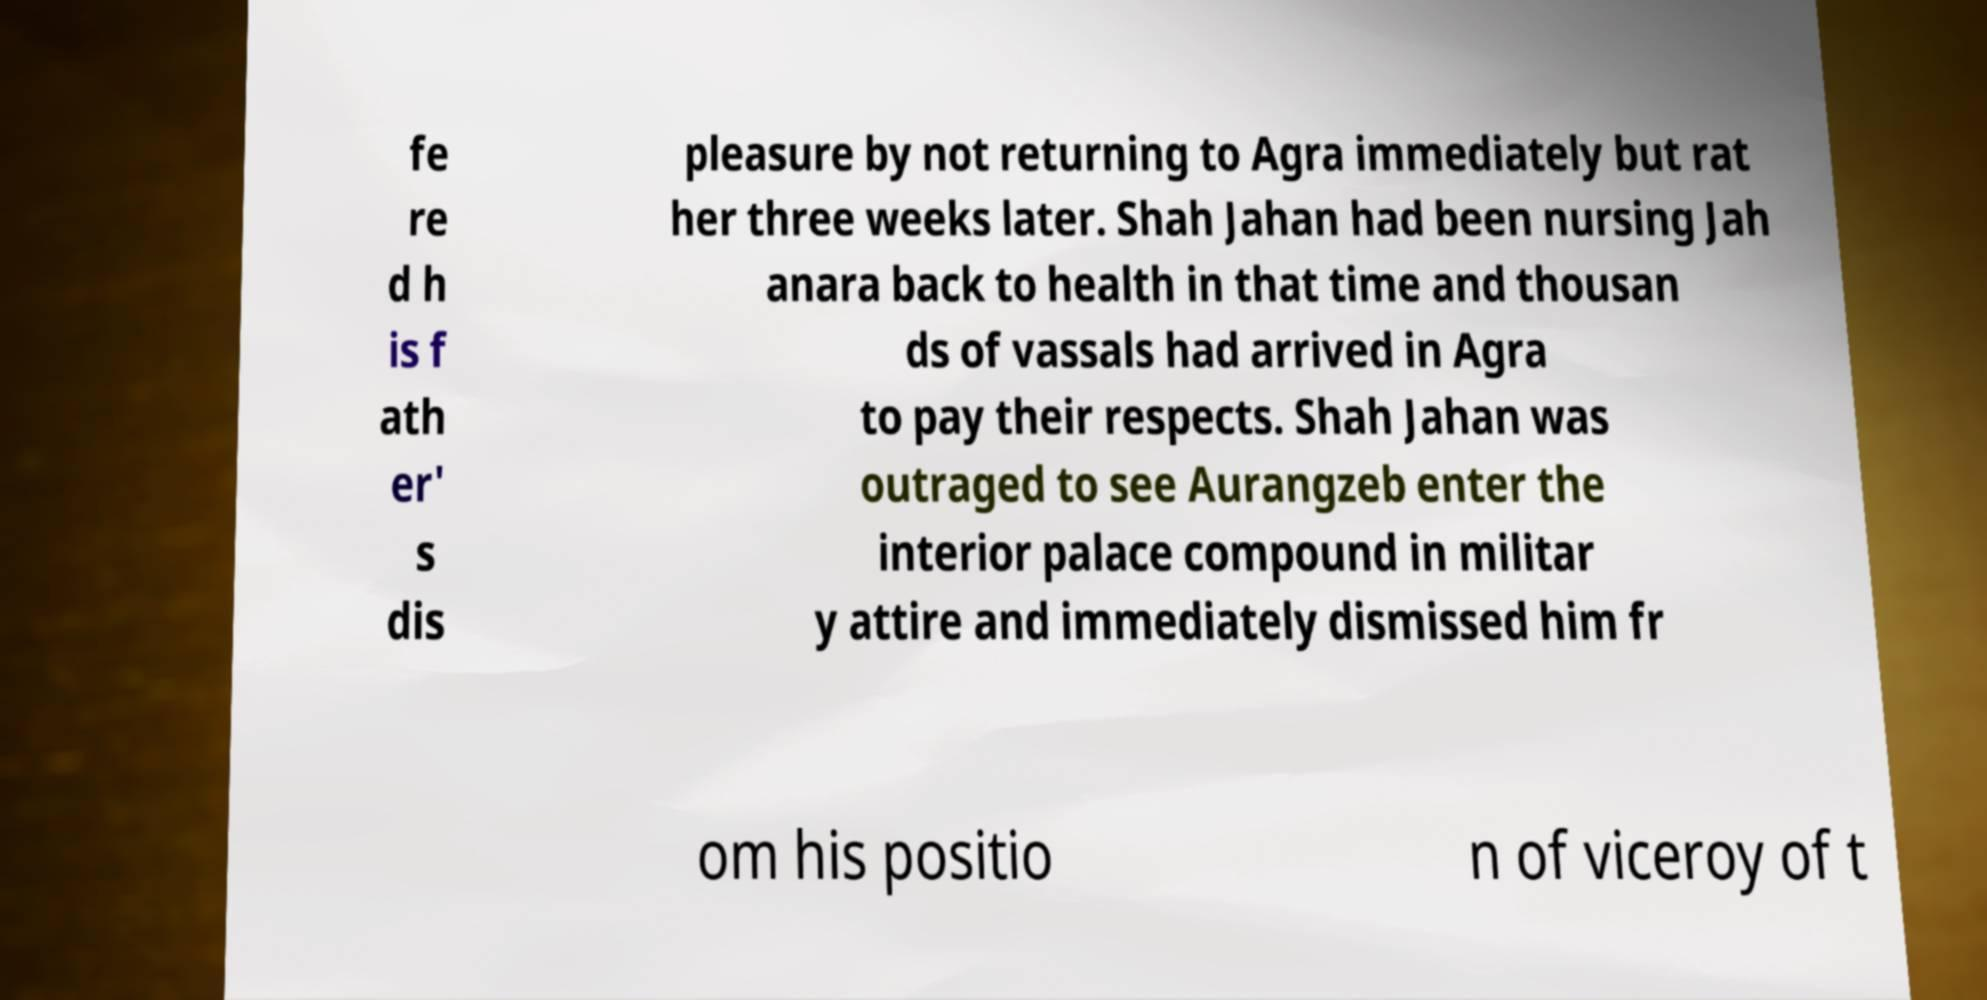Please read and relay the text visible in this image. What does it say? fe re d h is f ath er' s dis pleasure by not returning to Agra immediately but rat her three weeks later. Shah Jahan had been nursing Jah anara back to health in that time and thousan ds of vassals had arrived in Agra to pay their respects. Shah Jahan was outraged to see Aurangzeb enter the interior palace compound in militar y attire and immediately dismissed him fr om his positio n of viceroy of t 